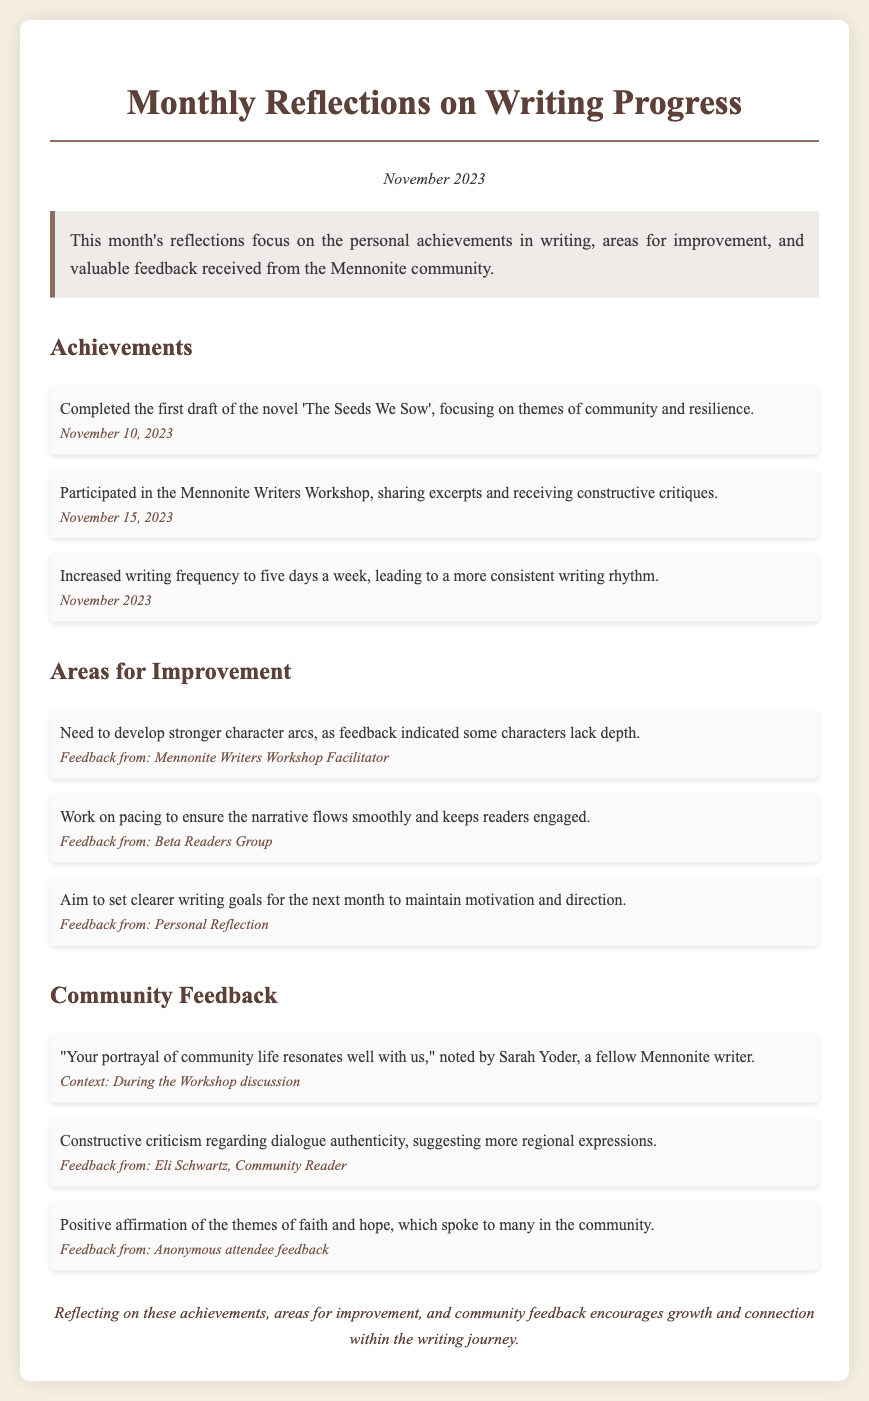What is the title of the completed novel? The title of the completed novel is specifically mentioned in the achievements section of the document.
Answer: The Seeds We Sow When was the first draft of the novel completed? The date of completion for the first draft is provided in the achievements section as the specific date.
Answer: November 10, 2023 How many writing days per week did the author increase to? The document states that the author increased writing frequency, specifying the number of days per week.
Answer: Five days What is one character-related area for improvement mentioned? The document outlines specific areas for improvement, including feedback from the Mennonite Writers Workshop.
Answer: Stronger character arcs Who provided feedback regarding dialogue authenticity? The source of feedback about dialogue authenticity is explicitly mentioned in the community feedback section of the document.
Answer: Eli Schwartz What theme was positively affirmed by the community? The document notes specific themes that resonated with the community, stating which theme received positive affirmation.
Answer: Faith and hope What is the date of the Mennonite Writers Workshop participation? The date of the event where the author participated is specified in the achievements section.
Answer: November 15, 2023 What kind of criticisms did the workshop feedback contain? The document references the nature of feedback received during the workshop and its focus on certain aspects of the author's writing.
Answer: Constructive criticism What kind of writing goals does the author aim to set? The document includes suggestions for future writing goals based on the author's reflections.
Answer: Clearer writing goals 